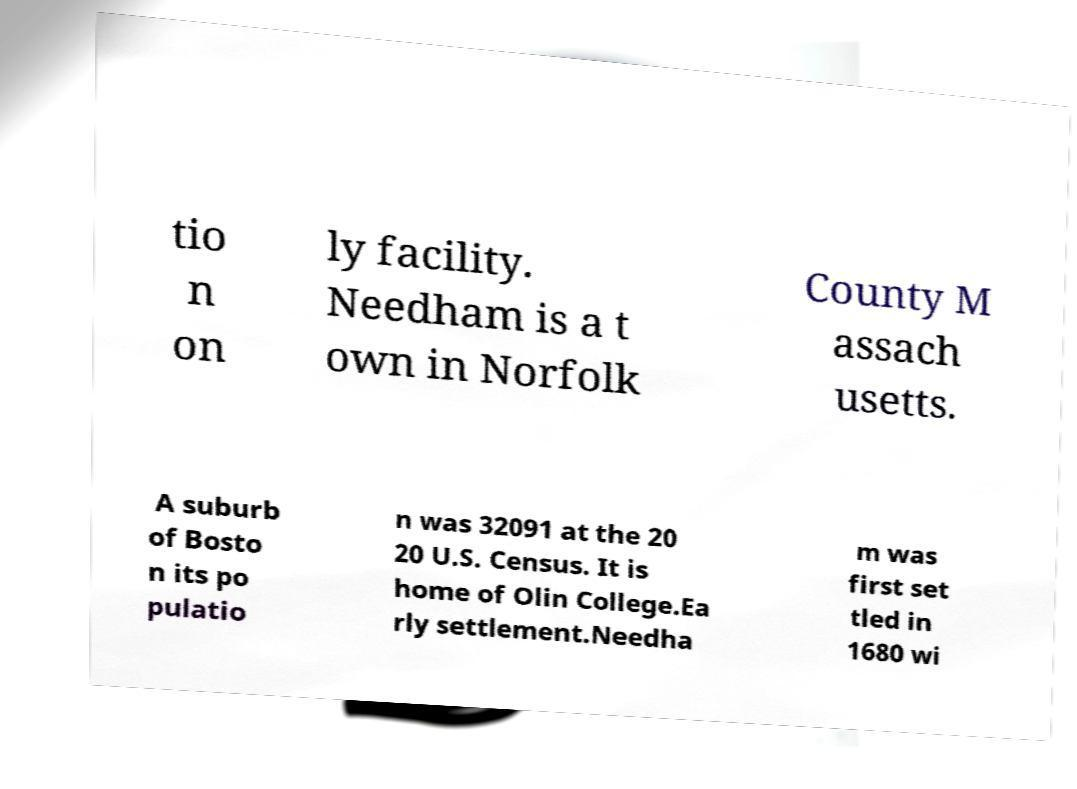Could you extract and type out the text from this image? tio n on ly facility. Needham is a t own in Norfolk County M assach usetts. A suburb of Bosto n its po pulatio n was 32091 at the 20 20 U.S. Census. It is home of Olin College.Ea rly settlement.Needha m was first set tled in 1680 wi 